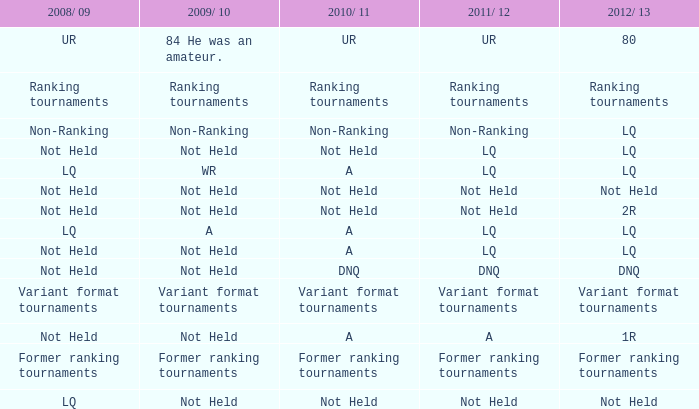What 2010/ 11 has not held as 2009/ 10, and 1r as the 2012/ 13? A. 